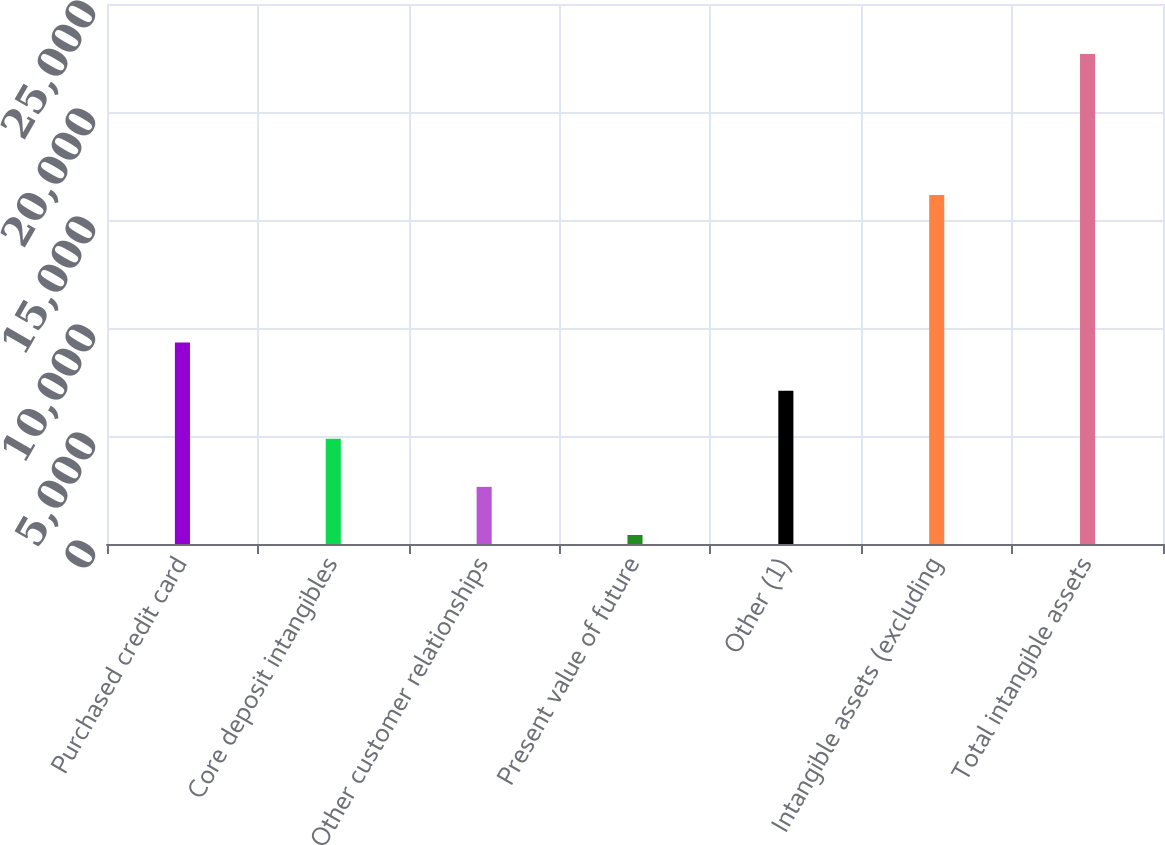Convert chart. <chart><loc_0><loc_0><loc_500><loc_500><bar_chart><fcel>Purchased credit card<fcel>Core deposit intangibles<fcel>Other customer relationships<fcel>Present value of future<fcel>Other (1)<fcel>Intangible assets (excluding<fcel>Total intangible assets<nl><fcel>9326.8<fcel>4872.4<fcel>2645.2<fcel>418<fcel>7099.6<fcel>16160<fcel>22690<nl></chart> 